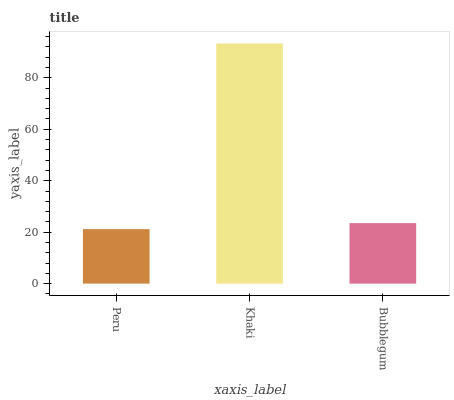Is Peru the minimum?
Answer yes or no. Yes. Is Khaki the maximum?
Answer yes or no. Yes. Is Bubblegum the minimum?
Answer yes or no. No. Is Bubblegum the maximum?
Answer yes or no. No. Is Khaki greater than Bubblegum?
Answer yes or no. Yes. Is Bubblegum less than Khaki?
Answer yes or no. Yes. Is Bubblegum greater than Khaki?
Answer yes or no. No. Is Khaki less than Bubblegum?
Answer yes or no. No. Is Bubblegum the high median?
Answer yes or no. Yes. Is Bubblegum the low median?
Answer yes or no. Yes. Is Khaki the high median?
Answer yes or no. No. Is Peru the low median?
Answer yes or no. No. 